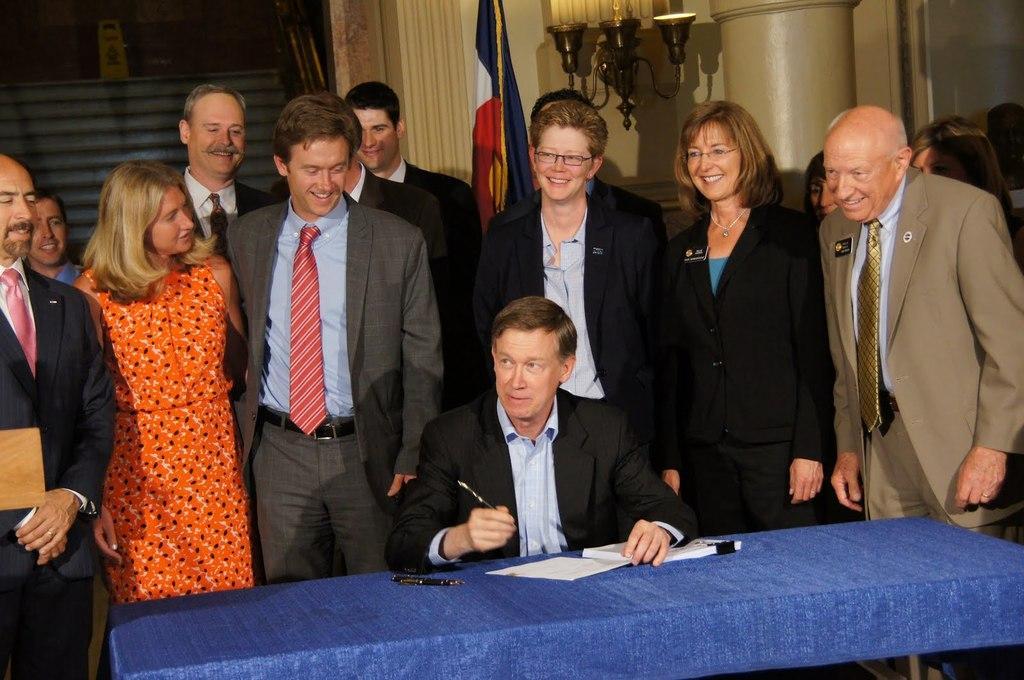Could you give a brief overview of what you see in this image? In this image, we can see a group of people. Among them, we can see a person is sitting and holding an object. We can also see a table covered with a blue cloth and some objects on it. In the background, we can see a wall, a flag and some lights. We can also see a pillar. 